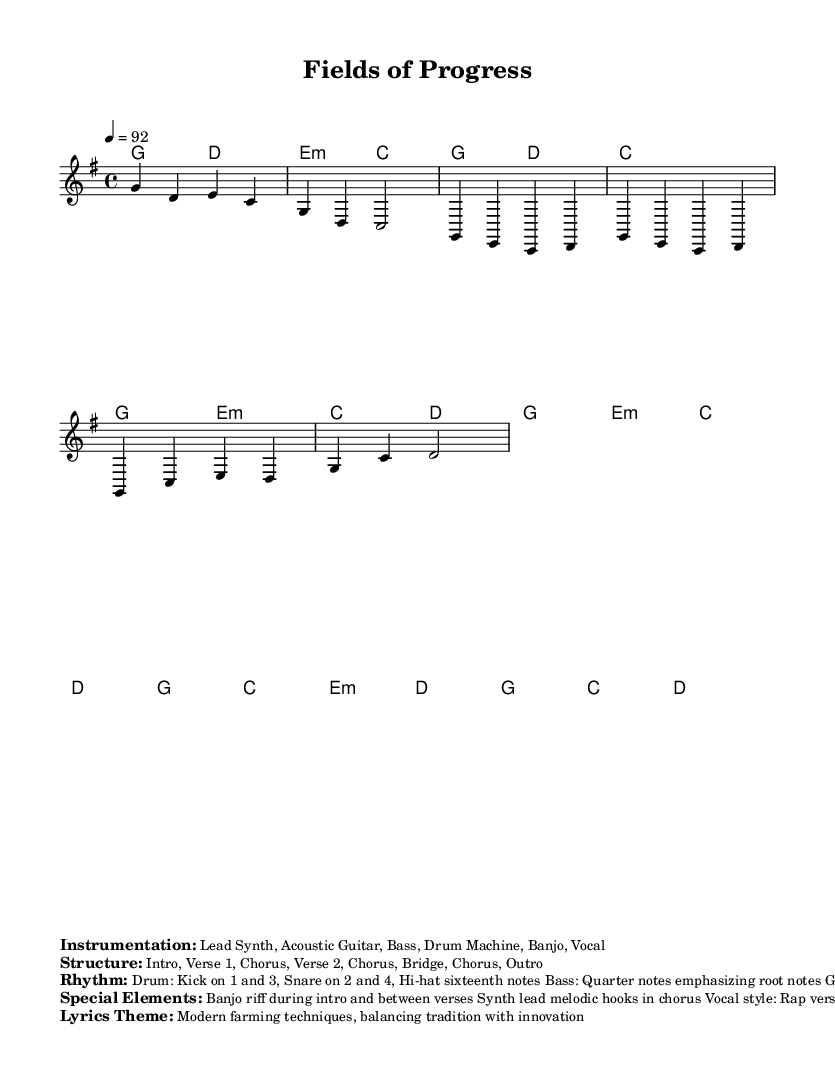What is the key signature of this music? The key signature is G major, which has one sharp (F#). This can be determined by looking at the key signature marking at the beginning of the sheet music.
Answer: G major What is the time signature of this music? The time signature is 4/4, indicated at the beginning of the music. This means there are four beats in each measure, and the quarter note receives one beat.
Answer: 4/4 What is the tempo marking for this music? The tempo is marked as 92 beats per minute, which can be found in the tempo marking at the start of the score. This indicates the speed at which the music should be played.
Answer: 92 How many verses are in the structure of the song? The structure includes two verses, as indicated by the breakdown of sections in the "Structure" markup. Each verse follows the chorus in the overall outline.
Answer: 2 What is the main instrumentation used in this piece? The primary instruments listed are Lead Synth, Acoustic Guitar, Bass, Drum Machine, Banjo, and Vocals. This information is provided under the "Instrumentation" section of the markup.
Answer: Lead Synth, Acoustic Guitar, Bass, Drum Machine, Banjo, Vocal What rhythmic elements are emphasized in the drum pattern of this music? The drum pattern emphasizes the kick on beats 1 and 3, and the snare on beats 2 and 4, with hi-hat playing sixteenth notes in between. This is detailed in the "Rhythm" section of the markup and reflects the hip hop fusion style.
Answer: Kick on 1 and 3, Snare on 2 and 4 What is the lyrical theme of this song? The lyrics focus on modern farming techniques, balancing tradition with innovation. This is explicitly stated in the "Lyrics Theme" section of the markup.
Answer: Modern farming techniques, balancing tradition with innovation 